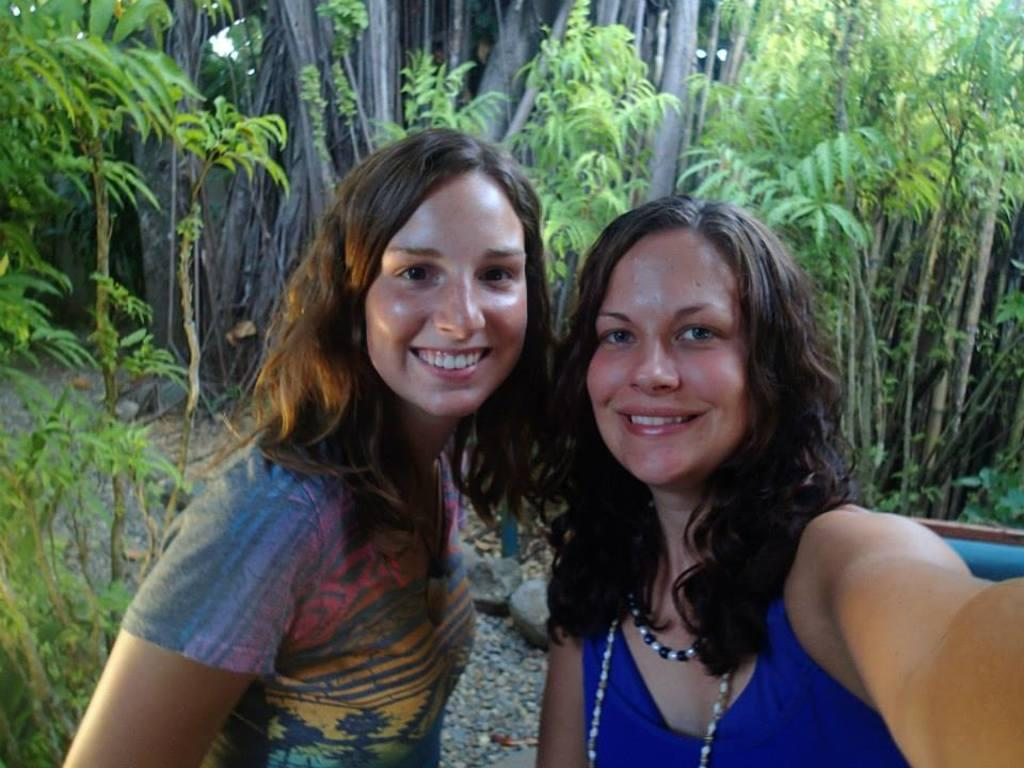How many people are in the image? There are two girls in the image. What are the girls doing in the image? The girls are smiling and taking a selfie with a camera. What can be seen in the background of the image? There are plants and tree branches in the background of the image. Can you tell me how many goldfish are swimming in the image? There are no goldfish present in the image; it features two girls taking a selfie with a camera. What type of board is being used by the girls in the image? There is no board visible in the image; the girls are using a camera to take a selfie. 